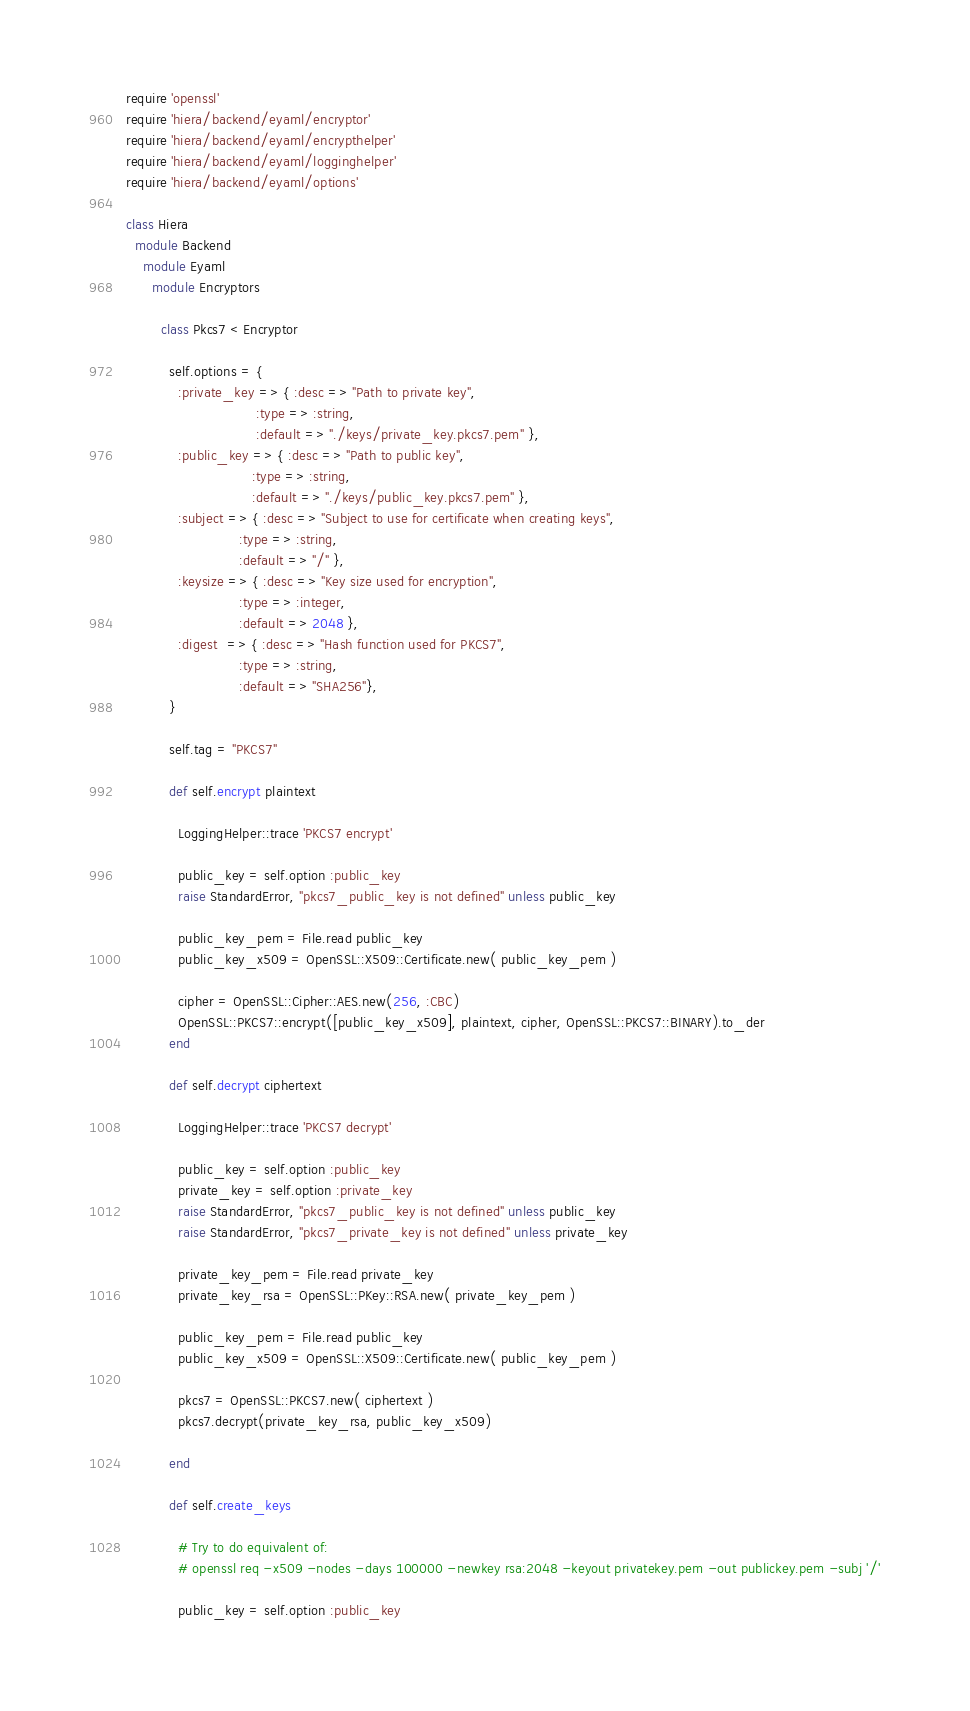Convert code to text. <code><loc_0><loc_0><loc_500><loc_500><_Ruby_>require 'openssl'
require 'hiera/backend/eyaml/encryptor'
require 'hiera/backend/eyaml/encrypthelper'
require 'hiera/backend/eyaml/logginghelper'
require 'hiera/backend/eyaml/options'

class Hiera
  module Backend
    module Eyaml
      module Encryptors

        class Pkcs7 < Encryptor

          self.options = {
            :private_key => { :desc => "Path to private key", 
                              :type => :string, 
                              :default => "./keys/private_key.pkcs7.pem" },
            :public_key => { :desc => "Path to public key",  
                             :type => :string, 
                             :default => "./keys/public_key.pkcs7.pem" },
            :subject => { :desc => "Subject to use for certificate when creating keys",
                          :type => :string,
                          :default => "/" },
            :keysize => { :desc => "Key size used for encryption",
                          :type => :integer,
                          :default => 2048 },
            :digest  => { :desc => "Hash function used for PKCS7",
                          :type => :string,
                          :default => "SHA256"},
          }

          self.tag = "PKCS7"

          def self.encrypt plaintext

            LoggingHelper::trace 'PKCS7 encrypt'

            public_key = self.option :public_key
            raise StandardError, "pkcs7_public_key is not defined" unless public_key

            public_key_pem = File.read public_key 
            public_key_x509 = OpenSSL::X509::Certificate.new( public_key_pem )

            cipher = OpenSSL::Cipher::AES.new(256, :CBC)
            OpenSSL::PKCS7::encrypt([public_key_x509], plaintext, cipher, OpenSSL::PKCS7::BINARY).to_der
          end

          def self.decrypt ciphertext

            LoggingHelper::trace 'PKCS7 decrypt'

            public_key = self.option :public_key
            private_key = self.option :private_key
            raise StandardError, "pkcs7_public_key is not defined" unless public_key
            raise StandardError, "pkcs7_private_key is not defined" unless private_key

            private_key_pem = File.read private_key
            private_key_rsa = OpenSSL::PKey::RSA.new( private_key_pem )

            public_key_pem = File.read public_key
            public_key_x509 = OpenSSL::X509::Certificate.new( public_key_pem )

            pkcs7 = OpenSSL::PKCS7.new( ciphertext )
            pkcs7.decrypt(private_key_rsa, public_key_x509)

          end

          def self.create_keys

            # Try to do equivalent of:
            # openssl req -x509 -nodes -days 100000 -newkey rsa:2048 -keyout privatekey.pem -out publickey.pem -subj '/'

            public_key = self.option :public_key</code> 